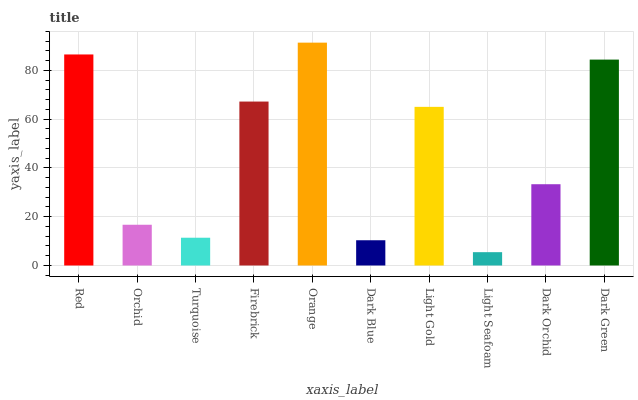Is Orchid the minimum?
Answer yes or no. No. Is Orchid the maximum?
Answer yes or no. No. Is Red greater than Orchid?
Answer yes or no. Yes. Is Orchid less than Red?
Answer yes or no. Yes. Is Orchid greater than Red?
Answer yes or no. No. Is Red less than Orchid?
Answer yes or no. No. Is Light Gold the high median?
Answer yes or no. Yes. Is Dark Orchid the low median?
Answer yes or no. Yes. Is Dark Blue the high median?
Answer yes or no. No. Is Firebrick the low median?
Answer yes or no. No. 